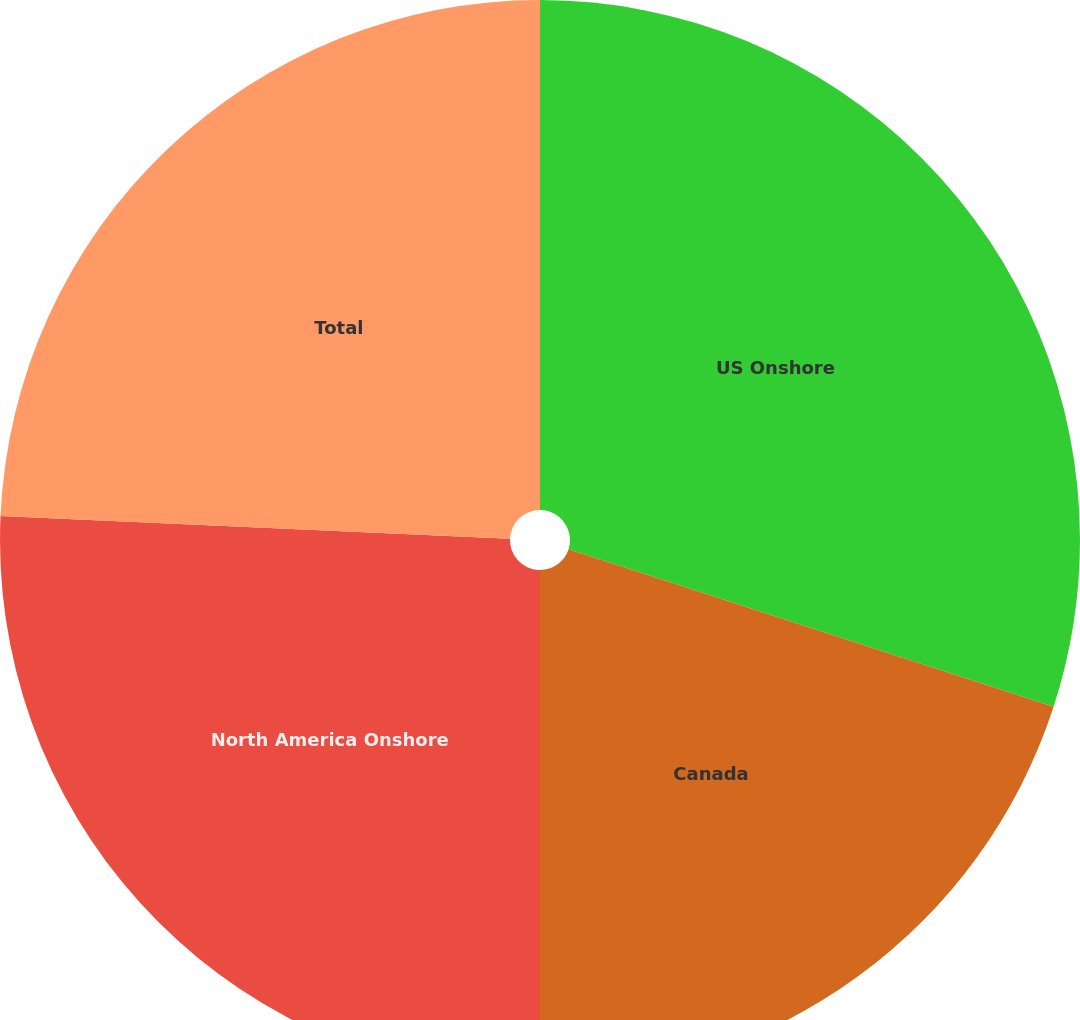Convert chart to OTSL. <chart><loc_0><loc_0><loc_500><loc_500><pie_chart><fcel>US Onshore<fcel>Canada<fcel>North America Onshore<fcel>Total<nl><fcel>30.0%<fcel>20.0%<fcel>25.71%<fcel>24.29%<nl></chart> 